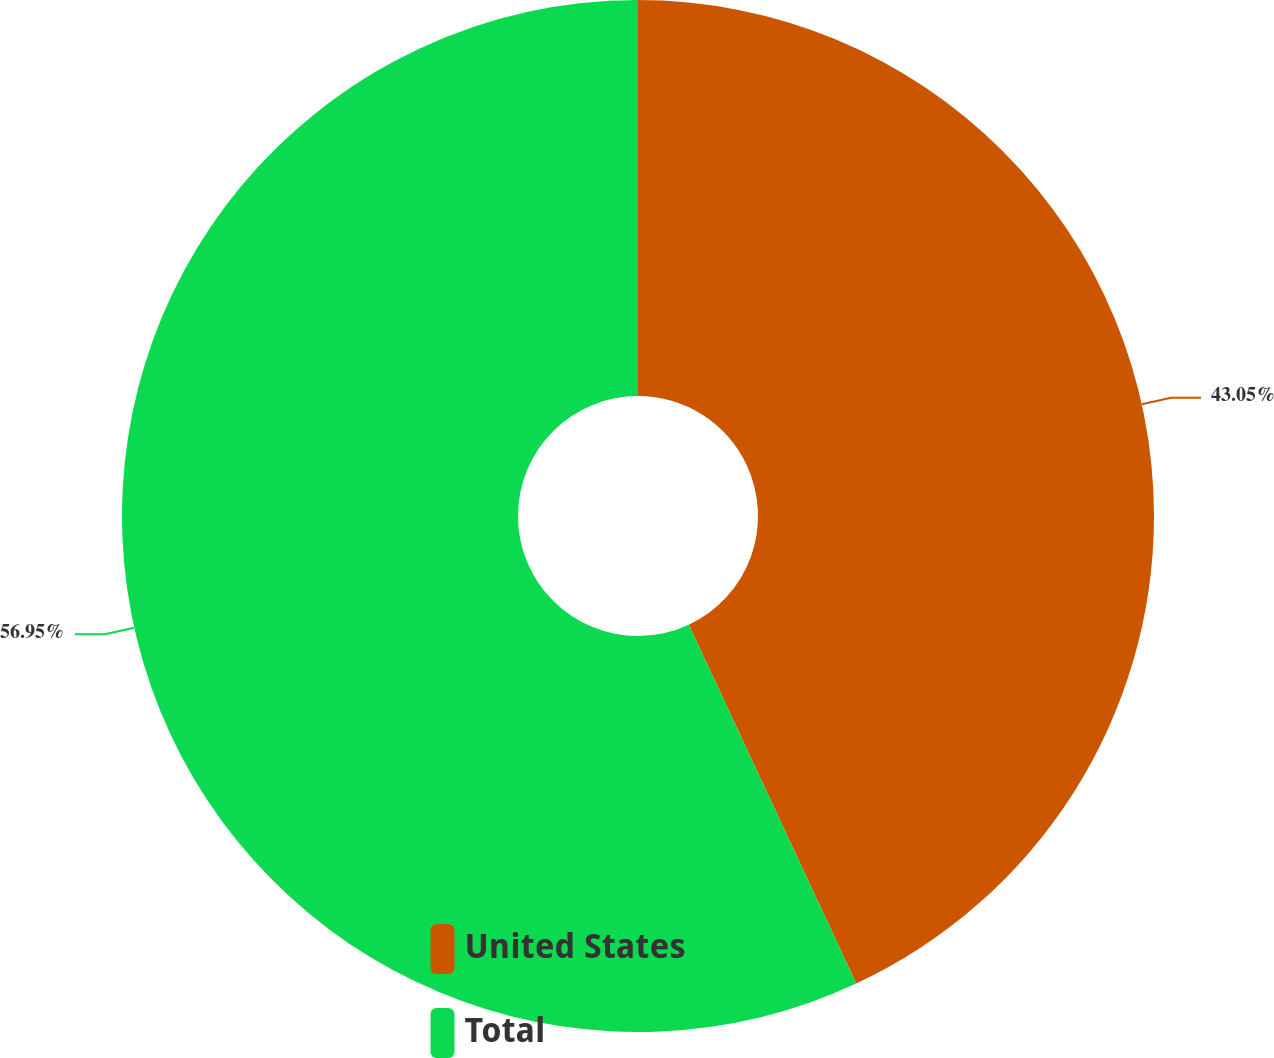Convert chart to OTSL. <chart><loc_0><loc_0><loc_500><loc_500><pie_chart><fcel>United States<fcel>Total<nl><fcel>43.05%<fcel>56.95%<nl></chart> 